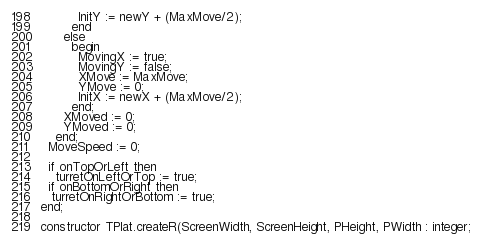Convert code to text. <code><loc_0><loc_0><loc_500><loc_500><_Pascal_>          InitY := newY + (MaxMove/2);
        end
      else
        begin
          MovingX := true;
          MovingY := false;
          XMove := MaxMove;
          YMove := 0;
          InitX := newX + (MaxMove/2);
        end;
      XMoved := 0;
      YMoved := 0;
    end;
  MoveSpeed := 0;

  if onTopOrLeft then
    turretOnLeftOrTop := true;
  if onBottomOrRight then
   turretOnRightOrBottom := true;
end;

constructor TPlat.createR(ScreenWidth, ScreenHeight, PHeight, PWidth : integer;</code> 